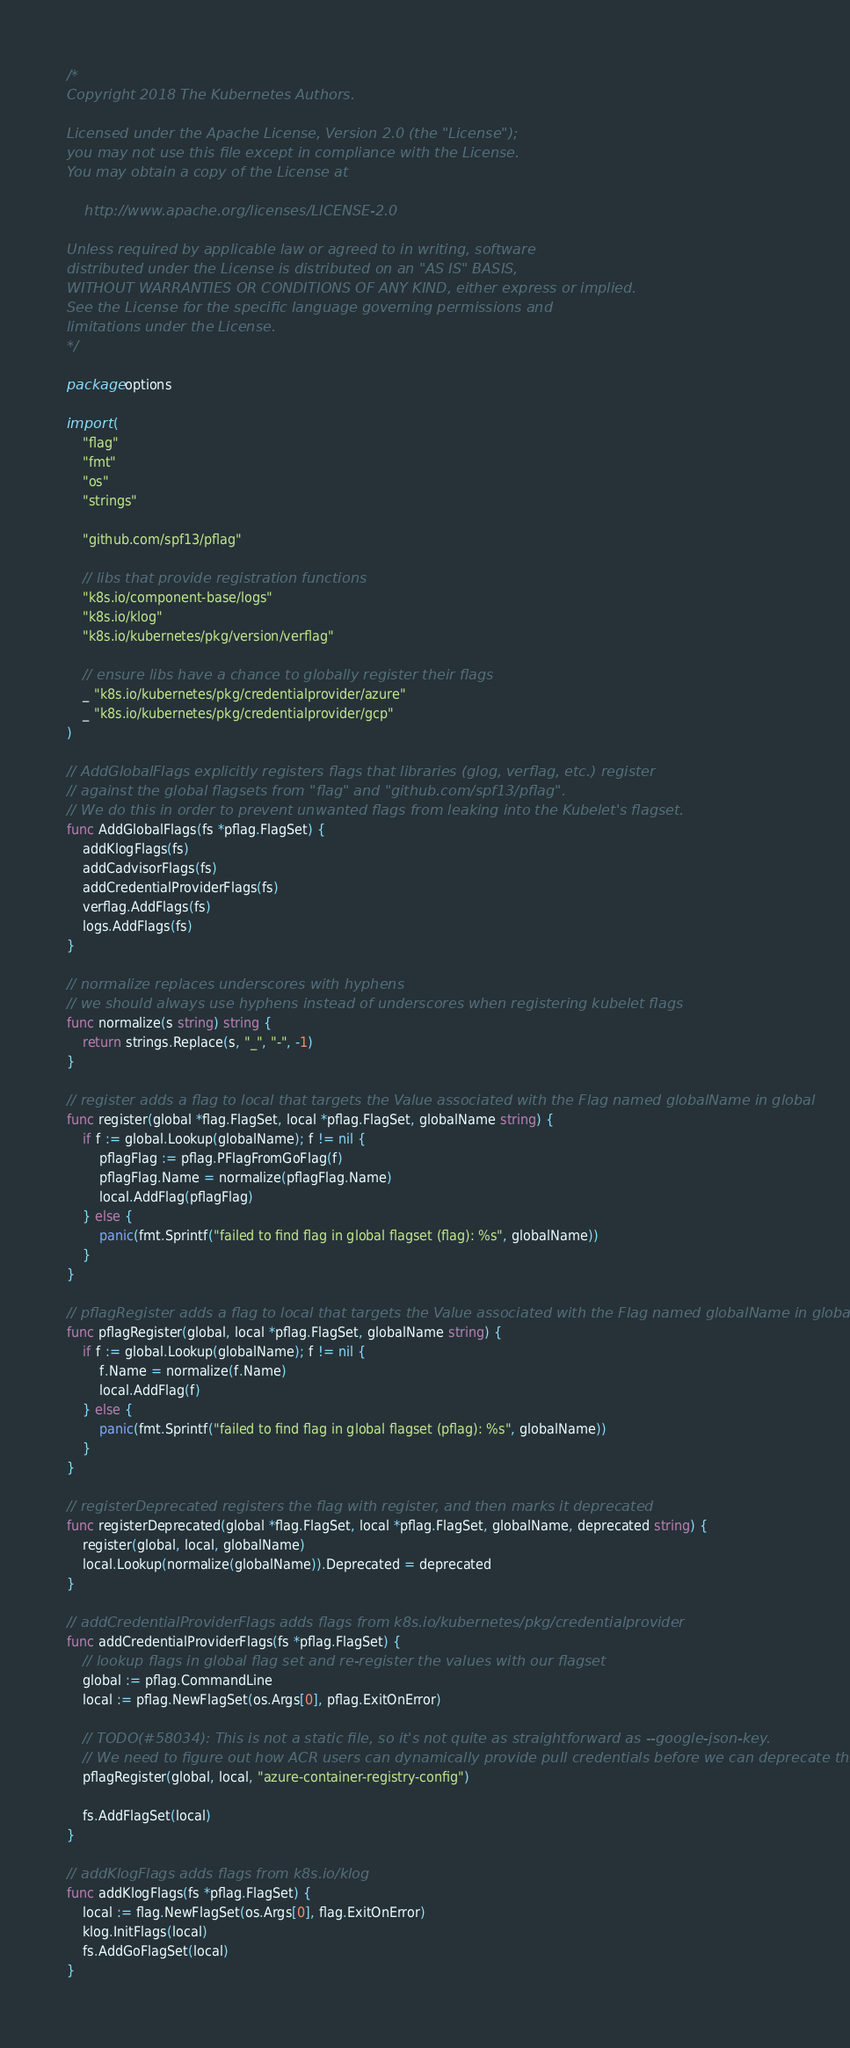Convert code to text. <code><loc_0><loc_0><loc_500><loc_500><_Go_>/*
Copyright 2018 The Kubernetes Authors.

Licensed under the Apache License, Version 2.0 (the "License");
you may not use this file except in compliance with the License.
You may obtain a copy of the License at

    http://www.apache.org/licenses/LICENSE-2.0

Unless required by applicable law or agreed to in writing, software
distributed under the License is distributed on an "AS IS" BASIS,
WITHOUT WARRANTIES OR CONDITIONS OF ANY KIND, either express or implied.
See the License for the specific language governing permissions and
limitations under the License.
*/

package options

import (
	"flag"
	"fmt"
	"os"
	"strings"

	"github.com/spf13/pflag"

	// libs that provide registration functions
	"k8s.io/component-base/logs"
	"k8s.io/klog"
	"k8s.io/kubernetes/pkg/version/verflag"

	// ensure libs have a chance to globally register their flags
	_ "k8s.io/kubernetes/pkg/credentialprovider/azure"
	_ "k8s.io/kubernetes/pkg/credentialprovider/gcp"
)

// AddGlobalFlags explicitly registers flags that libraries (glog, verflag, etc.) register
// against the global flagsets from "flag" and "github.com/spf13/pflag".
// We do this in order to prevent unwanted flags from leaking into the Kubelet's flagset.
func AddGlobalFlags(fs *pflag.FlagSet) {
	addKlogFlags(fs)
	addCadvisorFlags(fs)
	addCredentialProviderFlags(fs)
	verflag.AddFlags(fs)
	logs.AddFlags(fs)
}

// normalize replaces underscores with hyphens
// we should always use hyphens instead of underscores when registering kubelet flags
func normalize(s string) string {
	return strings.Replace(s, "_", "-", -1)
}

// register adds a flag to local that targets the Value associated with the Flag named globalName in global
func register(global *flag.FlagSet, local *pflag.FlagSet, globalName string) {
	if f := global.Lookup(globalName); f != nil {
		pflagFlag := pflag.PFlagFromGoFlag(f)
		pflagFlag.Name = normalize(pflagFlag.Name)
		local.AddFlag(pflagFlag)
	} else {
		panic(fmt.Sprintf("failed to find flag in global flagset (flag): %s", globalName))
	}
}

// pflagRegister adds a flag to local that targets the Value associated with the Flag named globalName in global
func pflagRegister(global, local *pflag.FlagSet, globalName string) {
	if f := global.Lookup(globalName); f != nil {
		f.Name = normalize(f.Name)
		local.AddFlag(f)
	} else {
		panic(fmt.Sprintf("failed to find flag in global flagset (pflag): %s", globalName))
	}
}

// registerDeprecated registers the flag with register, and then marks it deprecated
func registerDeprecated(global *flag.FlagSet, local *pflag.FlagSet, globalName, deprecated string) {
	register(global, local, globalName)
	local.Lookup(normalize(globalName)).Deprecated = deprecated
}

// addCredentialProviderFlags adds flags from k8s.io/kubernetes/pkg/credentialprovider
func addCredentialProviderFlags(fs *pflag.FlagSet) {
	// lookup flags in global flag set and re-register the values with our flagset
	global := pflag.CommandLine
	local := pflag.NewFlagSet(os.Args[0], pflag.ExitOnError)

	// TODO(#58034): This is not a static file, so it's not quite as straightforward as --google-json-key.
	// We need to figure out how ACR users can dynamically provide pull credentials before we can deprecate this.
	pflagRegister(global, local, "azure-container-registry-config")

	fs.AddFlagSet(local)
}

// addKlogFlags adds flags from k8s.io/klog
func addKlogFlags(fs *pflag.FlagSet) {
	local := flag.NewFlagSet(os.Args[0], flag.ExitOnError)
	klog.InitFlags(local)
	fs.AddGoFlagSet(local)
}
</code> 